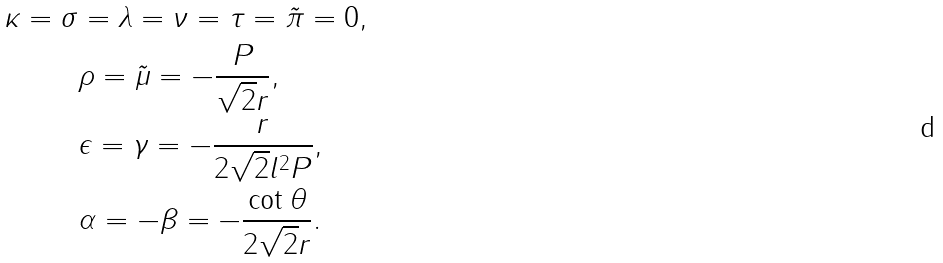<formula> <loc_0><loc_0><loc_500><loc_500>\kappa = \sigma & = \lambda = \nu = \tau = \tilde { \pi } = 0 , \\ & \rho = \tilde { \mu } = - \frac { P } { \sqrt { 2 } r } , \\ & \epsilon = \gamma = - \frac { r } { 2 \sqrt { 2 } l ^ { 2 } P } , \\ & \alpha = - \beta = - \frac { \cot \theta } { 2 \sqrt { 2 } r } .</formula> 